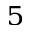Convert formula to latex. <formula><loc_0><loc_0><loc_500><loc_500>^ { 5 }</formula> 